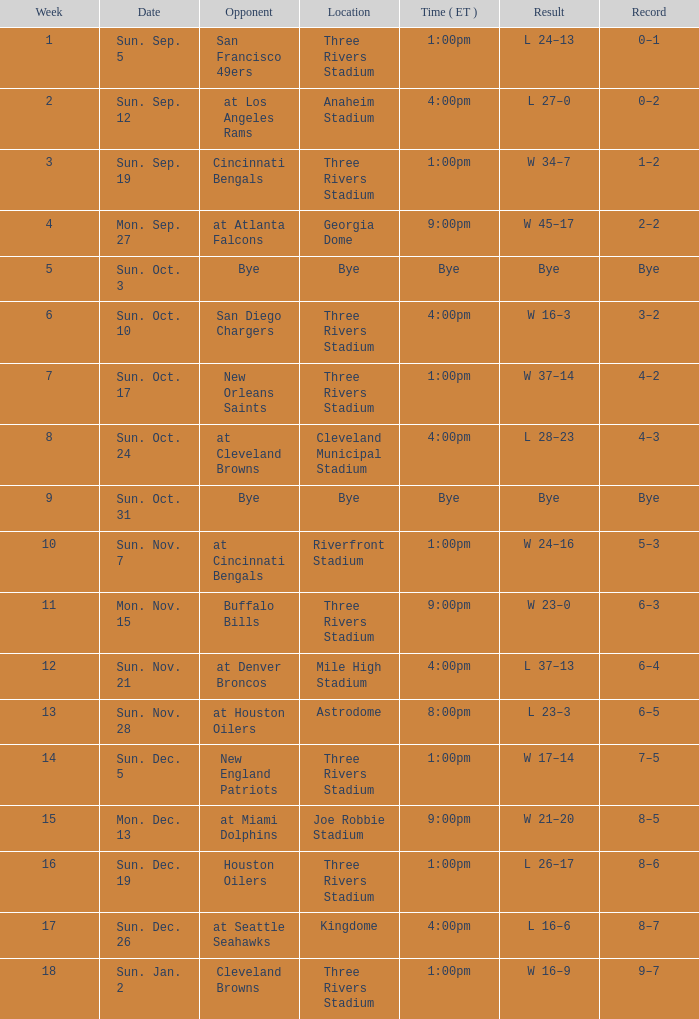What is the game's track record with a consequence of w 45-17? 2–2. 